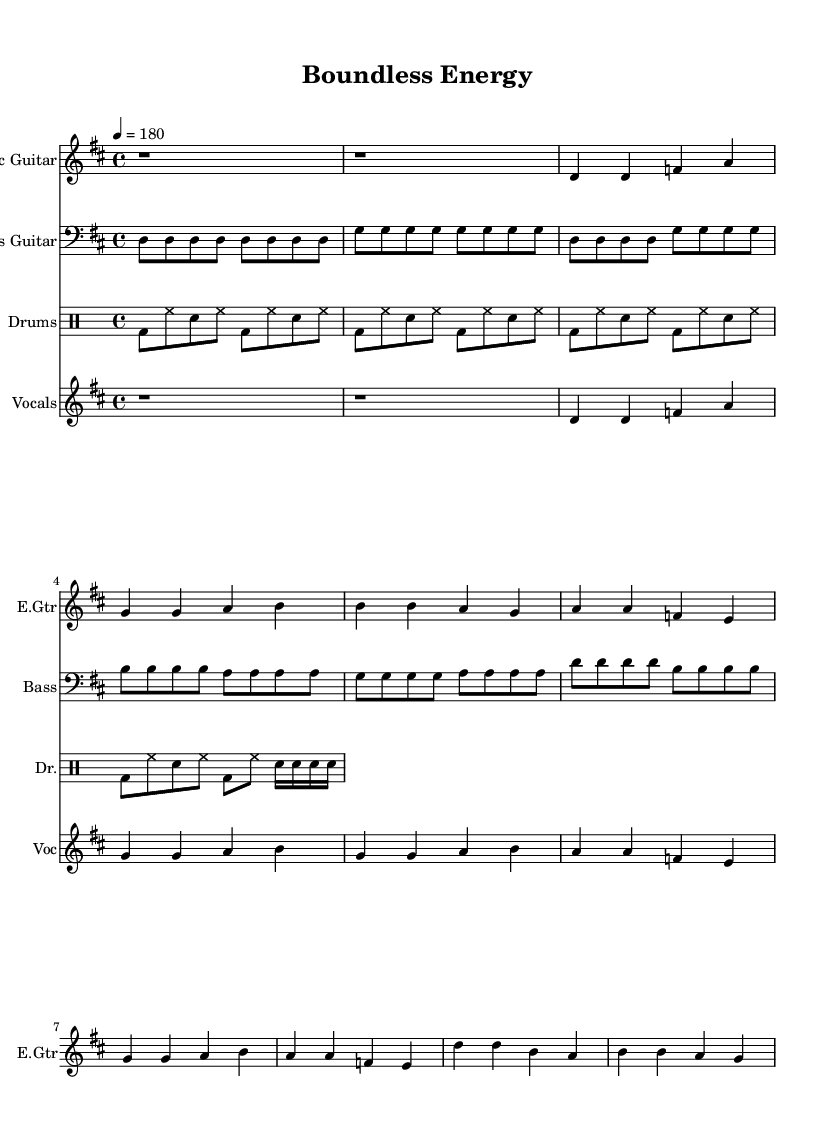What is the key signature of this music? The key signature in the score indicates that it is in D major, which has two sharps (F# and C#).
Answer: D major What is the time signature of this music? The time signature is represented at the beginning of the score, which is 4/4. This means there are four beats in each measure, and the quarter note gets one beat.
Answer: 4/4 What is the tempo marking of this piece? The tempo marking is indicated in the score as 4 = 180, meaning there are 180 beats per minute, and a quarter note gets the beat.
Answer: 180 How many sections are there in the song? The song consists of an intro, a verse, and a chorus. Counting these distinct parts gives us three sections.
Answer: Three What rhythm instrument is prominent in the music? The score contains a distinct part for drums with a basic punk beat, making drums the prominent rhythm instrument.
Answer: Drums In which verse do the lyrics mention "resilient hearts"? The lyrics that mention "resilient hearts" appear in the chorus section, where the vocal part is defined.
Answer: Chorus What is the primary theme of the lyrics? The lyrics focus on themes of resilience and strength in overcoming challenges, indicated by phrases such as "Playground warriors," and "unbreakable souls."
Answer: Resilience 